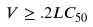Convert formula to latex. <formula><loc_0><loc_0><loc_500><loc_500>V \geq . 2 L C _ { 5 0 }</formula> 